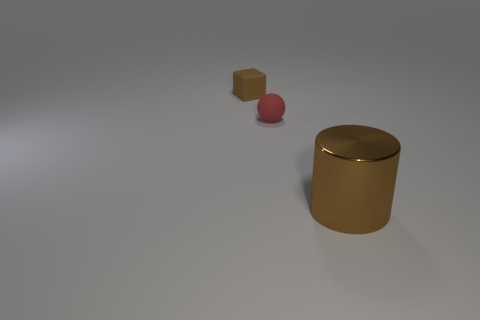There is a object that is the same color as the rubber cube; what is its size?
Make the answer very short. Large. Is there a brown object made of the same material as the brown cube?
Your response must be concise. No. The tiny rubber ball has what color?
Offer a very short reply. Red. What is the size of the rubber object that is left of the tiny rubber object that is on the right side of the brown object that is to the left of the brown metal thing?
Your answer should be very brief. Small. What number of other things are there of the same shape as the tiny brown matte thing?
Give a very brief answer. 0. There is a object that is on the right side of the brown block and to the left of the large brown object; what is its color?
Keep it short and to the point. Red. Is there anything else that is the same size as the shiny cylinder?
Ensure brevity in your answer.  No. Is the color of the tiny rubber thing that is on the right side of the brown block the same as the cube?
Give a very brief answer. No. How many spheres are either tiny objects or brown metal things?
Keep it short and to the point. 1. What is the shape of the brown object that is behind the big cylinder?
Provide a succinct answer. Cube. 